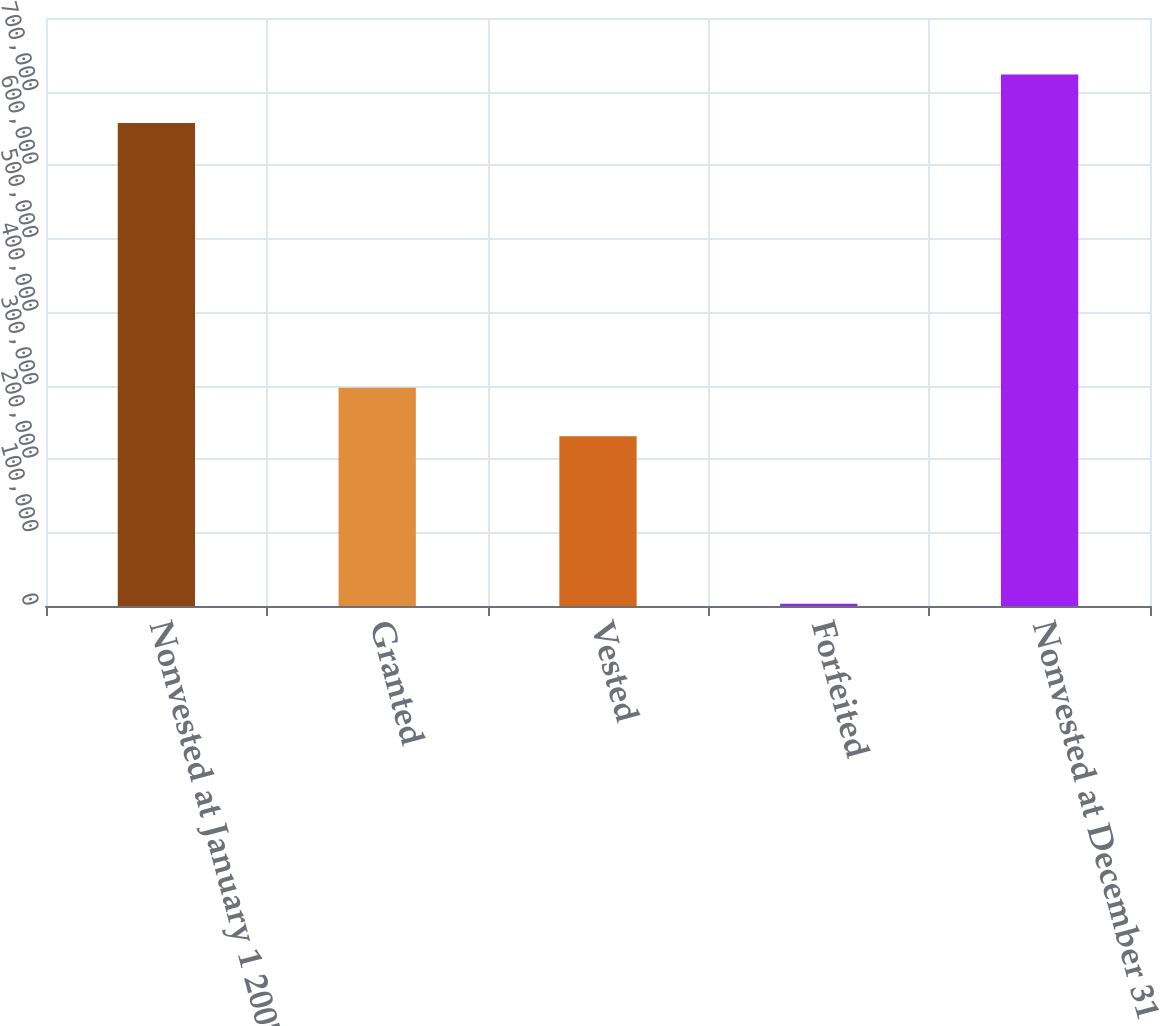Convert chart. <chart><loc_0><loc_0><loc_500><loc_500><bar_chart><fcel>Nonvested at January 1 2007<fcel>Granted<fcel>Vested<fcel>Forfeited<fcel>Nonvested at December 31 2007<nl><fcel>657000<fcel>297000<fcel>231000<fcel>3000<fcel>723000<nl></chart> 